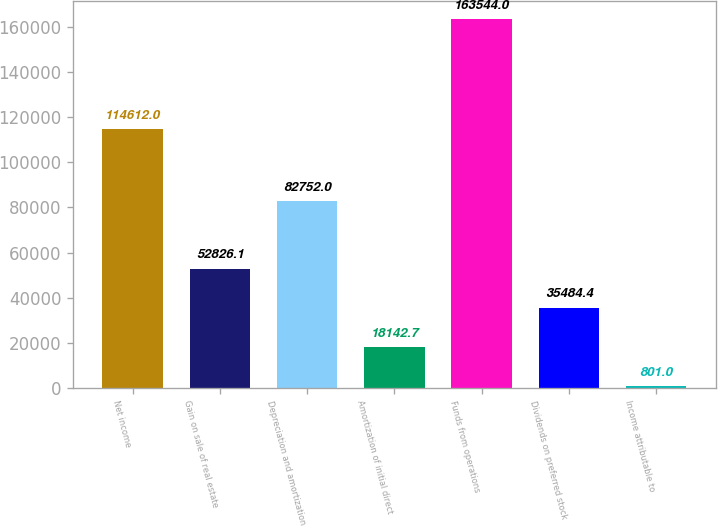Convert chart to OTSL. <chart><loc_0><loc_0><loc_500><loc_500><bar_chart><fcel>Net income<fcel>Gain on sale of real estate<fcel>Depreciation and amortization<fcel>Amortization of initial direct<fcel>Funds from operations<fcel>Dividends on preferred stock<fcel>Income attributable to<nl><fcel>114612<fcel>52826.1<fcel>82752<fcel>18142.7<fcel>163544<fcel>35484.4<fcel>801<nl></chart> 